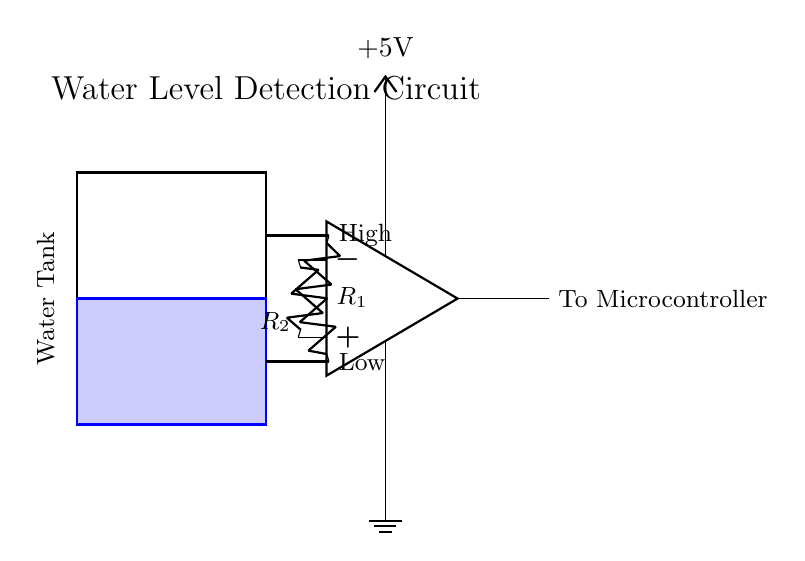What component indicates high water level? The component that indicates high water level is the probe connected to the upper resistor. When water reaches this level, the circuit will trigger the comparator due to the voltage difference.
Answer: probe connected to upper resistor What is the function of the op-amp in this circuit? The op-amp functions as a comparator to compare the voltage between the two probes and determine whether the water level is high or low. It outputs a signal accordingly to the microcontroller based on this comparison.
Answer: comparator How many resistors are present in the circuit? There are two resistors in the circuit, labeled as R1 and R2. Each resistor is connected in series with a probe to differentiate between high and low water levels.
Answer: two What is the voltage supply for this circuit? The voltage supply for this circuit is plus five volts, as indicated on the power supply line connected to the op-amp. This voltage is essential for the operation of the op-amp.
Answer: five volts What happens when the water level is low? When the water level is low, the voltage across the lower probe is lower than the voltage across the upper probe, leading to a specific output signal from the op-amp indicating a low water level.
Answer: output signal indicating low water level What does the output from the op-amp connect to? The output from the op-amp connects to the microcontroller, which processes the signal to manage water usage based on the detected water level.
Answer: microcontroller 